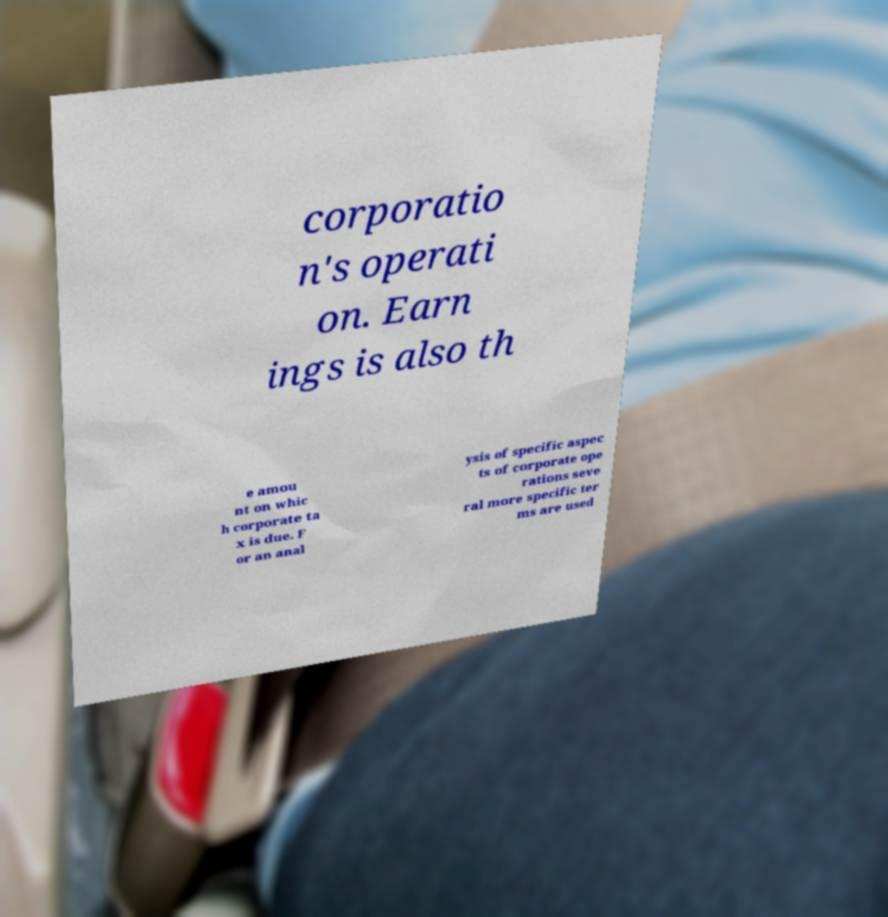Please identify and transcribe the text found in this image. corporatio n's operati on. Earn ings is also th e amou nt on whic h corporate ta x is due. F or an anal ysis of specific aspec ts of corporate ope rations seve ral more specific ter ms are used 